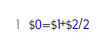Convert code to text. <code><loc_0><loc_0><loc_500><loc_500><_Awk_>$0=$1+$2/2</code> 